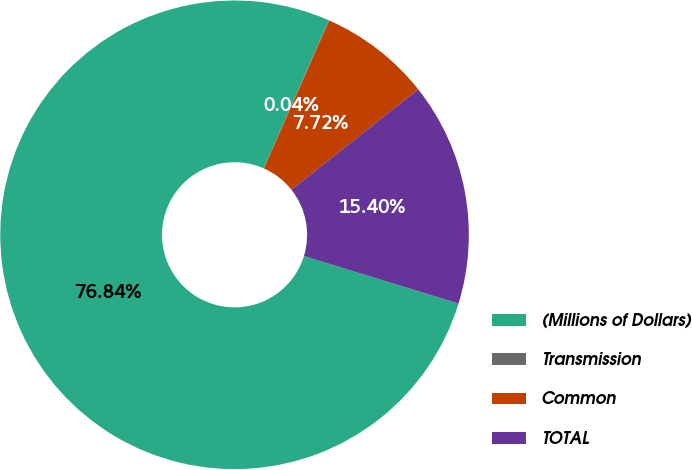<chart> <loc_0><loc_0><loc_500><loc_500><pie_chart><fcel>(Millions of Dollars)<fcel>Transmission<fcel>Common<fcel>TOTAL<nl><fcel>76.84%<fcel>0.04%<fcel>7.72%<fcel>15.4%<nl></chart> 